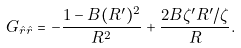Convert formula to latex. <formula><loc_0><loc_0><loc_500><loc_500>G _ { \hat { r } \hat { r } } = - \frac { 1 - B ( R ^ { \prime } ) ^ { 2 } } { R ^ { 2 } } + \frac { 2 B \zeta ^ { \prime } R ^ { \prime } / \zeta } { R } .</formula> 